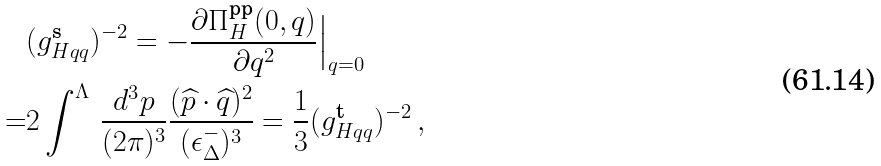Convert formula to latex. <formula><loc_0><loc_0><loc_500><loc_500>& ( g ^ { \text {s} } _ { H q q } ) ^ { - 2 } = - \frac { \partial \Pi ^ { \text {pp} } _ { H } ( 0 , q ) } { \partial q ^ { 2 } } \Big | _ { q = 0 } \\ = & 2 \int ^ { \Lambda } \, \frac { d ^ { 3 } p } { ( 2 \pi ) ^ { 3 } } \frac { ( \widehat { p } \cdot \widehat { q } ) ^ { 2 } } { ( \epsilon ^ { - } _ { \Delta } ) ^ { 3 } } = \frac { 1 } { 3 } ( g ^ { \text {t} } _ { H q q } ) ^ { - 2 } \, ,</formula> 